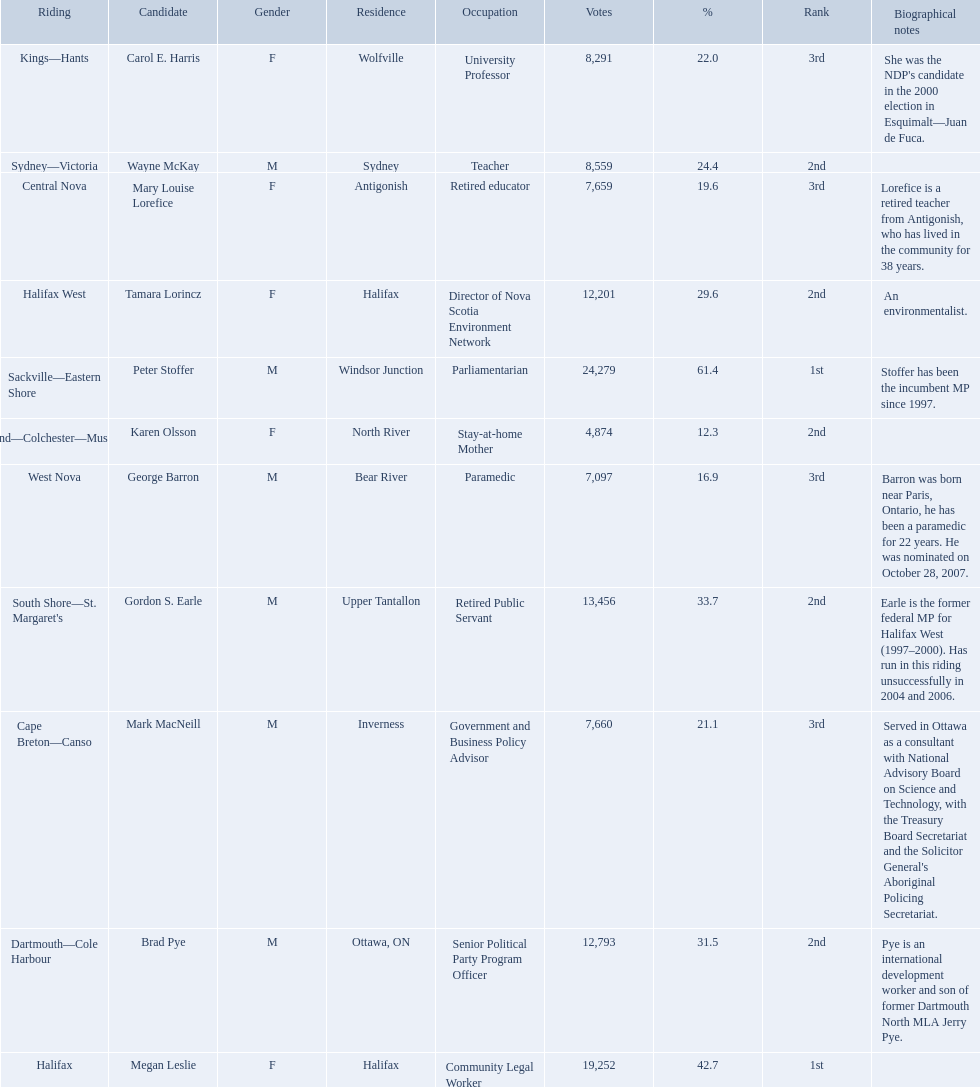What new democratic party candidates ran in the 2008 canadian federal election? Mark MacNeill, Mary Louise Lorefice, Karen Olsson, Brad Pye, Megan Leslie, Tamara Lorincz, Carol E. Harris, Peter Stoffer, Gordon S. Earle, Wayne McKay, George Barron. Of these candidates, which are female? Mary Louise Lorefice, Karen Olsson, Megan Leslie, Tamara Lorincz, Carol E. Harris. Which of these candidates resides in halifax? Megan Leslie, Tamara Lorincz. Of the remaining two, which was ranked 1st? Megan Leslie. Could you parse the entire table? {'header': ['Riding', 'Candidate', 'Gender', 'Residence', 'Occupation', 'Votes', '%', 'Rank', 'Biographical notes'], 'rows': [['Kings—Hants', 'Carol E. Harris', 'F', 'Wolfville', 'University Professor', '8,291', '22.0', '3rd', "She was the NDP's candidate in the 2000 election in Esquimalt—Juan de Fuca."], ['Sydney—Victoria', 'Wayne McKay', 'M', 'Sydney', 'Teacher', '8,559', '24.4', '2nd', ''], ['Central Nova', 'Mary Louise Lorefice', 'F', 'Antigonish', 'Retired educator', '7,659', '19.6', '3rd', 'Lorefice is a retired teacher from Antigonish, who has lived in the community for 38 years.'], ['Halifax West', 'Tamara Lorincz', 'F', 'Halifax', 'Director of Nova Scotia Environment Network', '12,201', '29.6', '2nd', 'An environmentalist.'], ['Sackville—Eastern Shore', 'Peter Stoffer', 'M', 'Windsor Junction', 'Parliamentarian', '24,279', '61.4', '1st', 'Stoffer has been the incumbent MP since 1997.'], ['Cumberland—Colchester—Musquodoboit Valley', 'Karen Olsson', 'F', 'North River', 'Stay-at-home Mother', '4,874', '12.3', '2nd', ''], ['West Nova', 'George Barron', 'M', 'Bear River', 'Paramedic', '7,097', '16.9', '3rd', 'Barron was born near Paris, Ontario, he has been a paramedic for 22 years. He was nominated on October 28, 2007.'], ["South Shore—St. Margaret's", 'Gordon S. Earle', 'M', 'Upper Tantallon', 'Retired Public Servant', '13,456', '33.7', '2nd', 'Earle is the former federal MP for Halifax West (1997–2000). Has run in this riding unsuccessfully in 2004 and 2006.'], ['Cape Breton—Canso', 'Mark MacNeill', 'M', 'Inverness', 'Government and Business Policy Advisor', '7,660', '21.1', '3rd', "Served in Ottawa as a consultant with National Advisory Board on Science and Technology, with the Treasury Board Secretariat and the Solicitor General's Aboriginal Policing Secretariat."], ['Dartmouth—Cole Harbour', 'Brad Pye', 'M', 'Ottawa, ON', 'Senior Political Party Program Officer', '12,793', '31.5', '2nd', 'Pye is an international development worker and son of former Dartmouth North MLA Jerry Pye.'], ['Halifax', 'Megan Leslie', 'F', 'Halifax', 'Community Legal Worker', '19,252', '42.7', '1st', '']]} How many votes did she get? 19,252. Who were all of the new democratic party candidates during the 2008 canadian federal election? Mark MacNeill, Mary Louise Lorefice, Karen Olsson, Brad Pye, Megan Leslie, Tamara Lorincz, Carol E. Harris, Peter Stoffer, Gordon S. Earle, Wayne McKay, George Barron. And between mark macneill and karen olsson, which candidate received more votes? Mark MacNeill. 